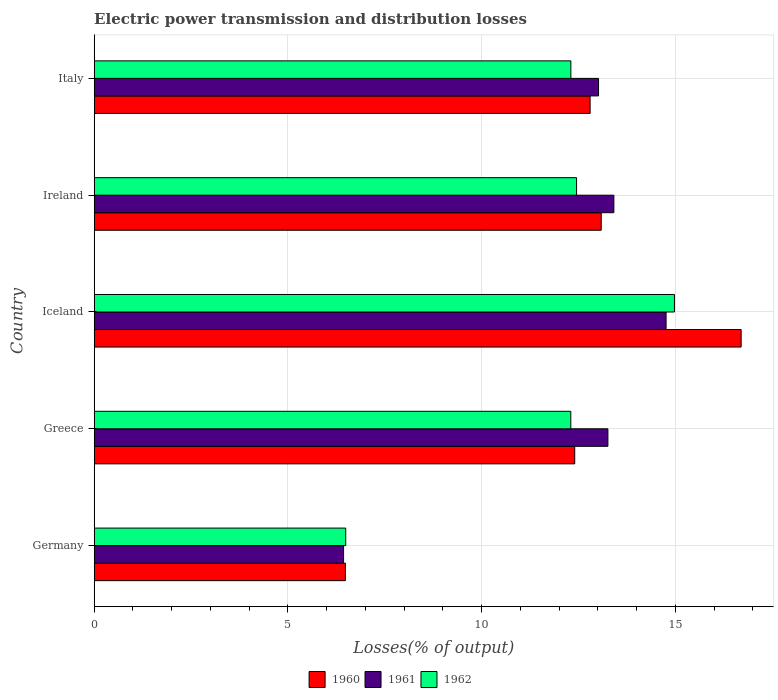Are the number of bars on each tick of the Y-axis equal?
Make the answer very short. Yes. How many bars are there on the 5th tick from the top?
Ensure brevity in your answer.  3. How many bars are there on the 5th tick from the bottom?
Give a very brief answer. 3. In how many cases, is the number of bars for a given country not equal to the number of legend labels?
Ensure brevity in your answer.  0. What is the electric power transmission and distribution losses in 1960 in Italy?
Keep it short and to the point. 12.8. Across all countries, what is the maximum electric power transmission and distribution losses in 1962?
Provide a short and direct response. 14.98. Across all countries, what is the minimum electric power transmission and distribution losses in 1960?
Your answer should be compact. 6.48. In which country was the electric power transmission and distribution losses in 1961 maximum?
Keep it short and to the point. Iceland. What is the total electric power transmission and distribution losses in 1962 in the graph?
Make the answer very short. 58.52. What is the difference between the electric power transmission and distribution losses in 1960 in Ireland and that in Italy?
Your answer should be compact. 0.29. What is the difference between the electric power transmission and distribution losses in 1961 in Ireland and the electric power transmission and distribution losses in 1960 in Germany?
Keep it short and to the point. 6.93. What is the average electric power transmission and distribution losses in 1961 per country?
Ensure brevity in your answer.  12.18. What is the difference between the electric power transmission and distribution losses in 1960 and electric power transmission and distribution losses in 1961 in Ireland?
Make the answer very short. -0.33. What is the ratio of the electric power transmission and distribution losses in 1960 in Iceland to that in Italy?
Ensure brevity in your answer.  1.3. Is the electric power transmission and distribution losses in 1962 in Germany less than that in Greece?
Keep it short and to the point. Yes. What is the difference between the highest and the second highest electric power transmission and distribution losses in 1960?
Your answer should be very brief. 3.61. What is the difference between the highest and the lowest electric power transmission and distribution losses in 1960?
Keep it short and to the point. 10.21. In how many countries, is the electric power transmission and distribution losses in 1961 greater than the average electric power transmission and distribution losses in 1961 taken over all countries?
Offer a very short reply. 4. How many bars are there?
Keep it short and to the point. 15. Are all the bars in the graph horizontal?
Your answer should be very brief. Yes. How many countries are there in the graph?
Ensure brevity in your answer.  5. What is the difference between two consecutive major ticks on the X-axis?
Ensure brevity in your answer.  5. Are the values on the major ticks of X-axis written in scientific E-notation?
Your answer should be very brief. No. Does the graph contain any zero values?
Your answer should be compact. No. Where does the legend appear in the graph?
Offer a terse response. Bottom center. How many legend labels are there?
Your response must be concise. 3. How are the legend labels stacked?
Ensure brevity in your answer.  Horizontal. What is the title of the graph?
Offer a terse response. Electric power transmission and distribution losses. What is the label or title of the X-axis?
Offer a very short reply. Losses(% of output). What is the Losses(% of output) in 1960 in Germany?
Give a very brief answer. 6.48. What is the Losses(% of output) in 1961 in Germany?
Provide a succinct answer. 6.44. What is the Losses(% of output) of 1962 in Germany?
Offer a terse response. 6.49. What is the Losses(% of output) in 1960 in Greece?
Ensure brevity in your answer.  12.4. What is the Losses(% of output) in 1961 in Greece?
Your answer should be very brief. 13.26. What is the Losses(% of output) of 1962 in Greece?
Your answer should be compact. 12.3. What is the Losses(% of output) in 1960 in Iceland?
Keep it short and to the point. 16.7. What is the Losses(% of output) in 1961 in Iceland?
Provide a short and direct response. 14.76. What is the Losses(% of output) of 1962 in Iceland?
Your response must be concise. 14.98. What is the Losses(% of output) of 1960 in Ireland?
Provide a short and direct response. 13.09. What is the Losses(% of output) of 1961 in Ireland?
Give a very brief answer. 13.41. What is the Losses(% of output) of 1962 in Ireland?
Make the answer very short. 12.45. What is the Losses(% of output) in 1960 in Italy?
Keep it short and to the point. 12.8. What is the Losses(% of output) in 1961 in Italy?
Offer a terse response. 13.02. What is the Losses(% of output) in 1962 in Italy?
Make the answer very short. 12.3. Across all countries, what is the maximum Losses(% of output) in 1960?
Your answer should be compact. 16.7. Across all countries, what is the maximum Losses(% of output) of 1961?
Provide a succinct answer. 14.76. Across all countries, what is the maximum Losses(% of output) of 1962?
Provide a succinct answer. 14.98. Across all countries, what is the minimum Losses(% of output) of 1960?
Offer a terse response. 6.48. Across all countries, what is the minimum Losses(% of output) in 1961?
Offer a terse response. 6.44. Across all countries, what is the minimum Losses(% of output) in 1962?
Keep it short and to the point. 6.49. What is the total Losses(% of output) in 1960 in the graph?
Provide a short and direct response. 61.47. What is the total Losses(% of output) in 1961 in the graph?
Ensure brevity in your answer.  60.88. What is the total Losses(% of output) of 1962 in the graph?
Offer a very short reply. 58.52. What is the difference between the Losses(% of output) of 1960 in Germany and that in Greece?
Offer a very short reply. -5.92. What is the difference between the Losses(% of output) of 1961 in Germany and that in Greece?
Provide a short and direct response. -6.82. What is the difference between the Losses(% of output) in 1962 in Germany and that in Greece?
Your answer should be compact. -5.81. What is the difference between the Losses(% of output) in 1960 in Germany and that in Iceland?
Offer a terse response. -10.21. What is the difference between the Losses(% of output) of 1961 in Germany and that in Iceland?
Give a very brief answer. -8.32. What is the difference between the Losses(% of output) of 1962 in Germany and that in Iceland?
Provide a short and direct response. -8.48. What is the difference between the Losses(% of output) of 1960 in Germany and that in Ireland?
Your answer should be very brief. -6.6. What is the difference between the Losses(% of output) in 1961 in Germany and that in Ireland?
Your answer should be very brief. -6.98. What is the difference between the Losses(% of output) in 1962 in Germany and that in Ireland?
Keep it short and to the point. -5.96. What is the difference between the Losses(% of output) of 1960 in Germany and that in Italy?
Provide a succinct answer. -6.32. What is the difference between the Losses(% of output) in 1961 in Germany and that in Italy?
Your response must be concise. -6.58. What is the difference between the Losses(% of output) in 1962 in Germany and that in Italy?
Offer a terse response. -5.81. What is the difference between the Losses(% of output) in 1960 in Greece and that in Iceland?
Your response must be concise. -4.3. What is the difference between the Losses(% of output) in 1961 in Greece and that in Iceland?
Ensure brevity in your answer.  -1.5. What is the difference between the Losses(% of output) of 1962 in Greece and that in Iceland?
Provide a short and direct response. -2.68. What is the difference between the Losses(% of output) in 1960 in Greece and that in Ireland?
Ensure brevity in your answer.  -0.68. What is the difference between the Losses(% of output) in 1961 in Greece and that in Ireland?
Your answer should be compact. -0.15. What is the difference between the Losses(% of output) of 1962 in Greece and that in Ireland?
Provide a short and direct response. -0.15. What is the difference between the Losses(% of output) in 1960 in Greece and that in Italy?
Give a very brief answer. -0.4. What is the difference between the Losses(% of output) of 1961 in Greece and that in Italy?
Give a very brief answer. 0.24. What is the difference between the Losses(% of output) of 1962 in Greece and that in Italy?
Keep it short and to the point. -0. What is the difference between the Losses(% of output) in 1960 in Iceland and that in Ireland?
Make the answer very short. 3.61. What is the difference between the Losses(% of output) of 1961 in Iceland and that in Ireland?
Offer a very short reply. 1.35. What is the difference between the Losses(% of output) in 1962 in Iceland and that in Ireland?
Keep it short and to the point. 2.53. What is the difference between the Losses(% of output) in 1960 in Iceland and that in Italy?
Ensure brevity in your answer.  3.9. What is the difference between the Losses(% of output) in 1961 in Iceland and that in Italy?
Ensure brevity in your answer.  1.74. What is the difference between the Losses(% of output) of 1962 in Iceland and that in Italy?
Keep it short and to the point. 2.67. What is the difference between the Losses(% of output) of 1960 in Ireland and that in Italy?
Your answer should be compact. 0.29. What is the difference between the Losses(% of output) of 1961 in Ireland and that in Italy?
Keep it short and to the point. 0.4. What is the difference between the Losses(% of output) in 1962 in Ireland and that in Italy?
Your answer should be very brief. 0.15. What is the difference between the Losses(% of output) in 1960 in Germany and the Losses(% of output) in 1961 in Greece?
Your answer should be very brief. -6.78. What is the difference between the Losses(% of output) of 1960 in Germany and the Losses(% of output) of 1962 in Greece?
Your answer should be very brief. -5.82. What is the difference between the Losses(% of output) in 1961 in Germany and the Losses(% of output) in 1962 in Greece?
Your answer should be compact. -5.86. What is the difference between the Losses(% of output) of 1960 in Germany and the Losses(% of output) of 1961 in Iceland?
Provide a short and direct response. -8.28. What is the difference between the Losses(% of output) of 1960 in Germany and the Losses(% of output) of 1962 in Iceland?
Your answer should be compact. -8.49. What is the difference between the Losses(% of output) in 1961 in Germany and the Losses(% of output) in 1962 in Iceland?
Offer a terse response. -8.54. What is the difference between the Losses(% of output) of 1960 in Germany and the Losses(% of output) of 1961 in Ireland?
Your answer should be very brief. -6.93. What is the difference between the Losses(% of output) of 1960 in Germany and the Losses(% of output) of 1962 in Ireland?
Your response must be concise. -5.97. What is the difference between the Losses(% of output) in 1961 in Germany and the Losses(% of output) in 1962 in Ireland?
Offer a terse response. -6.01. What is the difference between the Losses(% of output) in 1960 in Germany and the Losses(% of output) in 1961 in Italy?
Ensure brevity in your answer.  -6.53. What is the difference between the Losses(% of output) in 1960 in Germany and the Losses(% of output) in 1962 in Italy?
Ensure brevity in your answer.  -5.82. What is the difference between the Losses(% of output) in 1961 in Germany and the Losses(% of output) in 1962 in Italy?
Give a very brief answer. -5.87. What is the difference between the Losses(% of output) in 1960 in Greece and the Losses(% of output) in 1961 in Iceland?
Ensure brevity in your answer.  -2.36. What is the difference between the Losses(% of output) of 1960 in Greece and the Losses(% of output) of 1962 in Iceland?
Offer a very short reply. -2.57. What is the difference between the Losses(% of output) in 1961 in Greece and the Losses(% of output) in 1962 in Iceland?
Your response must be concise. -1.72. What is the difference between the Losses(% of output) of 1960 in Greece and the Losses(% of output) of 1961 in Ireland?
Offer a very short reply. -1.01. What is the difference between the Losses(% of output) of 1960 in Greece and the Losses(% of output) of 1962 in Ireland?
Make the answer very short. -0.05. What is the difference between the Losses(% of output) of 1961 in Greece and the Losses(% of output) of 1962 in Ireland?
Make the answer very short. 0.81. What is the difference between the Losses(% of output) of 1960 in Greece and the Losses(% of output) of 1961 in Italy?
Your answer should be very brief. -0.61. What is the difference between the Losses(% of output) in 1960 in Greece and the Losses(% of output) in 1962 in Italy?
Keep it short and to the point. 0.1. What is the difference between the Losses(% of output) of 1961 in Greece and the Losses(% of output) of 1962 in Italy?
Offer a terse response. 0.96. What is the difference between the Losses(% of output) in 1960 in Iceland and the Losses(% of output) in 1961 in Ireland?
Keep it short and to the point. 3.28. What is the difference between the Losses(% of output) in 1960 in Iceland and the Losses(% of output) in 1962 in Ireland?
Ensure brevity in your answer.  4.25. What is the difference between the Losses(% of output) of 1961 in Iceland and the Losses(% of output) of 1962 in Ireland?
Give a very brief answer. 2.31. What is the difference between the Losses(% of output) in 1960 in Iceland and the Losses(% of output) in 1961 in Italy?
Your answer should be compact. 3.68. What is the difference between the Losses(% of output) in 1960 in Iceland and the Losses(% of output) in 1962 in Italy?
Your answer should be very brief. 4.39. What is the difference between the Losses(% of output) in 1961 in Iceland and the Losses(% of output) in 1962 in Italy?
Your answer should be very brief. 2.46. What is the difference between the Losses(% of output) of 1960 in Ireland and the Losses(% of output) of 1961 in Italy?
Offer a very short reply. 0.07. What is the difference between the Losses(% of output) in 1960 in Ireland and the Losses(% of output) in 1962 in Italy?
Give a very brief answer. 0.78. What is the difference between the Losses(% of output) of 1961 in Ireland and the Losses(% of output) of 1962 in Italy?
Provide a short and direct response. 1.11. What is the average Losses(% of output) in 1960 per country?
Your answer should be very brief. 12.29. What is the average Losses(% of output) of 1961 per country?
Make the answer very short. 12.18. What is the average Losses(% of output) of 1962 per country?
Your answer should be compact. 11.7. What is the difference between the Losses(% of output) in 1960 and Losses(% of output) in 1961 in Germany?
Provide a succinct answer. 0.05. What is the difference between the Losses(% of output) of 1960 and Losses(% of output) of 1962 in Germany?
Keep it short and to the point. -0.01. What is the difference between the Losses(% of output) of 1961 and Losses(% of output) of 1962 in Germany?
Provide a short and direct response. -0.06. What is the difference between the Losses(% of output) of 1960 and Losses(% of output) of 1961 in Greece?
Make the answer very short. -0.86. What is the difference between the Losses(% of output) of 1960 and Losses(% of output) of 1962 in Greece?
Make the answer very short. 0.1. What is the difference between the Losses(% of output) in 1961 and Losses(% of output) in 1962 in Greece?
Give a very brief answer. 0.96. What is the difference between the Losses(% of output) of 1960 and Losses(% of output) of 1961 in Iceland?
Make the answer very short. 1.94. What is the difference between the Losses(% of output) of 1960 and Losses(% of output) of 1962 in Iceland?
Make the answer very short. 1.72. What is the difference between the Losses(% of output) of 1961 and Losses(% of output) of 1962 in Iceland?
Offer a very short reply. -0.22. What is the difference between the Losses(% of output) in 1960 and Losses(% of output) in 1961 in Ireland?
Keep it short and to the point. -0.33. What is the difference between the Losses(% of output) in 1960 and Losses(% of output) in 1962 in Ireland?
Give a very brief answer. 0.64. What is the difference between the Losses(% of output) in 1961 and Losses(% of output) in 1962 in Ireland?
Offer a terse response. 0.96. What is the difference between the Losses(% of output) of 1960 and Losses(% of output) of 1961 in Italy?
Offer a very short reply. -0.22. What is the difference between the Losses(% of output) of 1960 and Losses(% of output) of 1962 in Italy?
Ensure brevity in your answer.  0.5. What is the difference between the Losses(% of output) of 1961 and Losses(% of output) of 1962 in Italy?
Give a very brief answer. 0.71. What is the ratio of the Losses(% of output) in 1960 in Germany to that in Greece?
Offer a terse response. 0.52. What is the ratio of the Losses(% of output) in 1961 in Germany to that in Greece?
Keep it short and to the point. 0.49. What is the ratio of the Losses(% of output) of 1962 in Germany to that in Greece?
Offer a very short reply. 0.53. What is the ratio of the Losses(% of output) in 1960 in Germany to that in Iceland?
Ensure brevity in your answer.  0.39. What is the ratio of the Losses(% of output) in 1961 in Germany to that in Iceland?
Provide a short and direct response. 0.44. What is the ratio of the Losses(% of output) of 1962 in Germany to that in Iceland?
Your answer should be compact. 0.43. What is the ratio of the Losses(% of output) in 1960 in Germany to that in Ireland?
Keep it short and to the point. 0.5. What is the ratio of the Losses(% of output) in 1961 in Germany to that in Ireland?
Keep it short and to the point. 0.48. What is the ratio of the Losses(% of output) in 1962 in Germany to that in Ireland?
Give a very brief answer. 0.52. What is the ratio of the Losses(% of output) in 1960 in Germany to that in Italy?
Give a very brief answer. 0.51. What is the ratio of the Losses(% of output) in 1961 in Germany to that in Italy?
Your response must be concise. 0.49. What is the ratio of the Losses(% of output) of 1962 in Germany to that in Italy?
Keep it short and to the point. 0.53. What is the ratio of the Losses(% of output) of 1960 in Greece to that in Iceland?
Make the answer very short. 0.74. What is the ratio of the Losses(% of output) of 1961 in Greece to that in Iceland?
Provide a short and direct response. 0.9. What is the ratio of the Losses(% of output) in 1962 in Greece to that in Iceland?
Your response must be concise. 0.82. What is the ratio of the Losses(% of output) in 1960 in Greece to that in Ireland?
Your answer should be very brief. 0.95. What is the ratio of the Losses(% of output) of 1962 in Greece to that in Ireland?
Make the answer very short. 0.99. What is the ratio of the Losses(% of output) of 1961 in Greece to that in Italy?
Your response must be concise. 1.02. What is the ratio of the Losses(% of output) of 1962 in Greece to that in Italy?
Your answer should be compact. 1. What is the ratio of the Losses(% of output) in 1960 in Iceland to that in Ireland?
Provide a succinct answer. 1.28. What is the ratio of the Losses(% of output) of 1961 in Iceland to that in Ireland?
Keep it short and to the point. 1.1. What is the ratio of the Losses(% of output) in 1962 in Iceland to that in Ireland?
Your answer should be compact. 1.2. What is the ratio of the Losses(% of output) of 1960 in Iceland to that in Italy?
Your response must be concise. 1.3. What is the ratio of the Losses(% of output) in 1961 in Iceland to that in Italy?
Provide a succinct answer. 1.13. What is the ratio of the Losses(% of output) of 1962 in Iceland to that in Italy?
Offer a terse response. 1.22. What is the ratio of the Losses(% of output) of 1960 in Ireland to that in Italy?
Offer a terse response. 1.02. What is the ratio of the Losses(% of output) of 1961 in Ireland to that in Italy?
Your response must be concise. 1.03. What is the ratio of the Losses(% of output) of 1962 in Ireland to that in Italy?
Keep it short and to the point. 1.01. What is the difference between the highest and the second highest Losses(% of output) in 1960?
Keep it short and to the point. 3.61. What is the difference between the highest and the second highest Losses(% of output) in 1961?
Your answer should be compact. 1.35. What is the difference between the highest and the second highest Losses(% of output) in 1962?
Provide a short and direct response. 2.53. What is the difference between the highest and the lowest Losses(% of output) of 1960?
Your answer should be compact. 10.21. What is the difference between the highest and the lowest Losses(% of output) in 1961?
Provide a short and direct response. 8.32. What is the difference between the highest and the lowest Losses(% of output) in 1962?
Offer a very short reply. 8.48. 